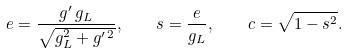<formula> <loc_0><loc_0><loc_500><loc_500>e = \frac { g ^ { \prime } \, g _ { L } } { \sqrt { g _ { L } ^ { 2 } + g ^ { \prime \, 2 } } } , \quad s = \frac { e } { g _ { L } } , \quad c = \sqrt { 1 - s ^ { 2 } } .</formula> 